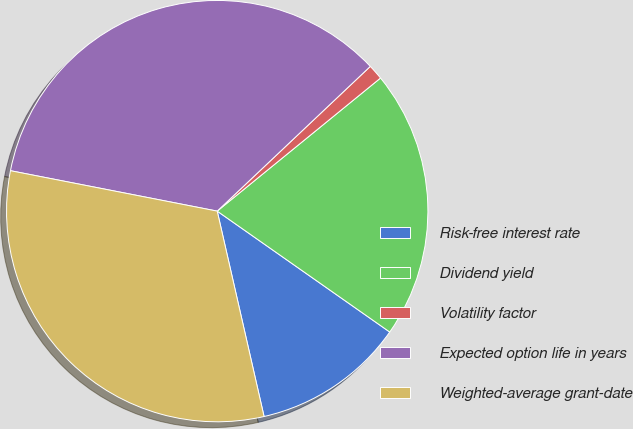Convert chart to OTSL. <chart><loc_0><loc_0><loc_500><loc_500><pie_chart><fcel>Risk-free interest rate<fcel>Dividend yield<fcel>Volatility factor<fcel>Expected option life in years<fcel>Weighted-average grant-date<nl><fcel>11.7%<fcel>20.61%<fcel>1.17%<fcel>34.87%<fcel>31.64%<nl></chart> 